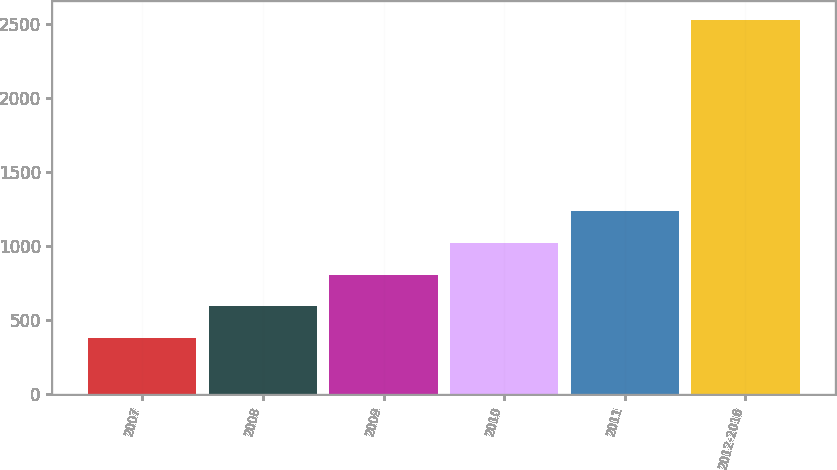Convert chart to OTSL. <chart><loc_0><loc_0><loc_500><loc_500><bar_chart><fcel>2007<fcel>2008<fcel>2009<fcel>2010<fcel>2011<fcel>2012-2016<nl><fcel>380<fcel>594.4<fcel>808.8<fcel>1023.2<fcel>1237.6<fcel>2524<nl></chart> 